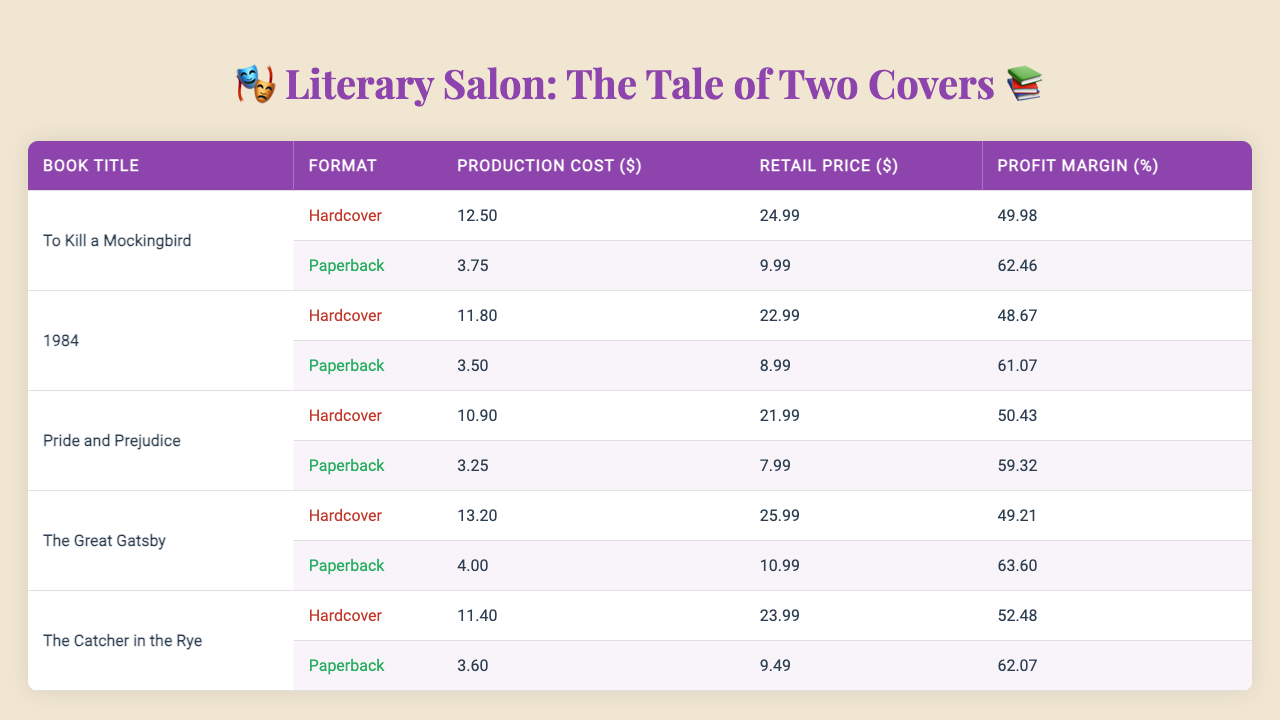What is the production cost of the hardcover edition of "1984"? The production cost for the hardcover edition of "1984" is listed in the table as $11.80.
Answer: $11.80 Which book has the highest profit margin for its paperback edition? The profit margin for the paperback editions are as follows: "To Kill a Mockingbird" (62.46%), "1984" (61.07%), "Pride and Prejudice" (59.32%), "The Great Gatsby" (63.60%), and "The Catcher in the Rye" (62.07%). The highest profit margin is for "The Great Gatsby" at 63.60%.
Answer: "The Great Gatsby" What is the difference between the retail price of hardcover and paperback editions for "Pride and Prejudice"? The retail price for hardcover is $21.99, and for paperback, it's $7.99. The difference is $21.99 - $7.99 = $14.00.
Answer: $14.00 What is the average production cost of hardcover editions across all books? The production costs for hardcover editions are $12.50, $11.80, $10.90, $13.20, and $11.40. Adding them gives $12.50 + $11.80 + $10.90 + $13.20 + $11.40 = $59.80, and dividing by 5 gives an average of $59.80 / 5 = $11.96.
Answer: $11.96 Is the retail price of the hardcover edition of "The Great Gatsby" greater than that of the paperback edition? The retail price for the hardcover edition is $25.99, while for the paperback, it is $10.99. Since $25.99 is greater than $10.99, the statement is true.
Answer: Yes If we compare the profit margins of "To Kill a Mockingbird" in both formats, how much more does the hardcover edition profit compared to the paperback edition? The profit margin for hardcover is 49.98%, and for paperback, it's 62.46%. To find the difference, we calculate 62.46% - 49.98% = 12.48%. Therefore, the hardcover edition profits 12.48% less than the paperback edition.
Answer: 12.48% What is the total profit margin for hardcover editions of all the listed books combined? The profit margins for hardcover are: 49.98%, 48.67%, 50.43%, 49.21%, and 52.48%. Summing these gives 49.98 + 48.67 + 50.43 + 49.21 + 52.48 = 250.77%. To find the average, we divide by 5, leading to a total profit margin of 250.77% / 5 = 50.15%.
Answer: 50.15% 